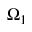Convert formula to latex. <formula><loc_0><loc_0><loc_500><loc_500>\Omega _ { 1 }</formula> 